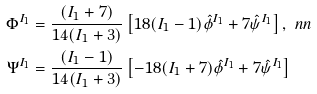<formula> <loc_0><loc_0><loc_500><loc_500>& \Phi ^ { I _ { 1 } } = \frac { ( I _ { 1 } + 7 ) } { 1 4 ( I _ { 1 } + 3 ) } \left [ 1 8 ( I _ { 1 } - 1 ) \hat { \phi } ^ { I _ { 1 } } + 7 \hat { \psi } ^ { I _ { 1 } } \right ] , \ n n \\ & \Psi ^ { I _ { 1 } } = \frac { ( I _ { 1 } - 1 ) } { 1 4 ( I _ { 1 } + 3 ) } \left [ - 1 8 ( I _ { 1 } + 7 ) \hat { \phi } ^ { I _ { 1 } } + 7 \hat { \psi } ^ { I _ { 1 } } \right ]</formula> 